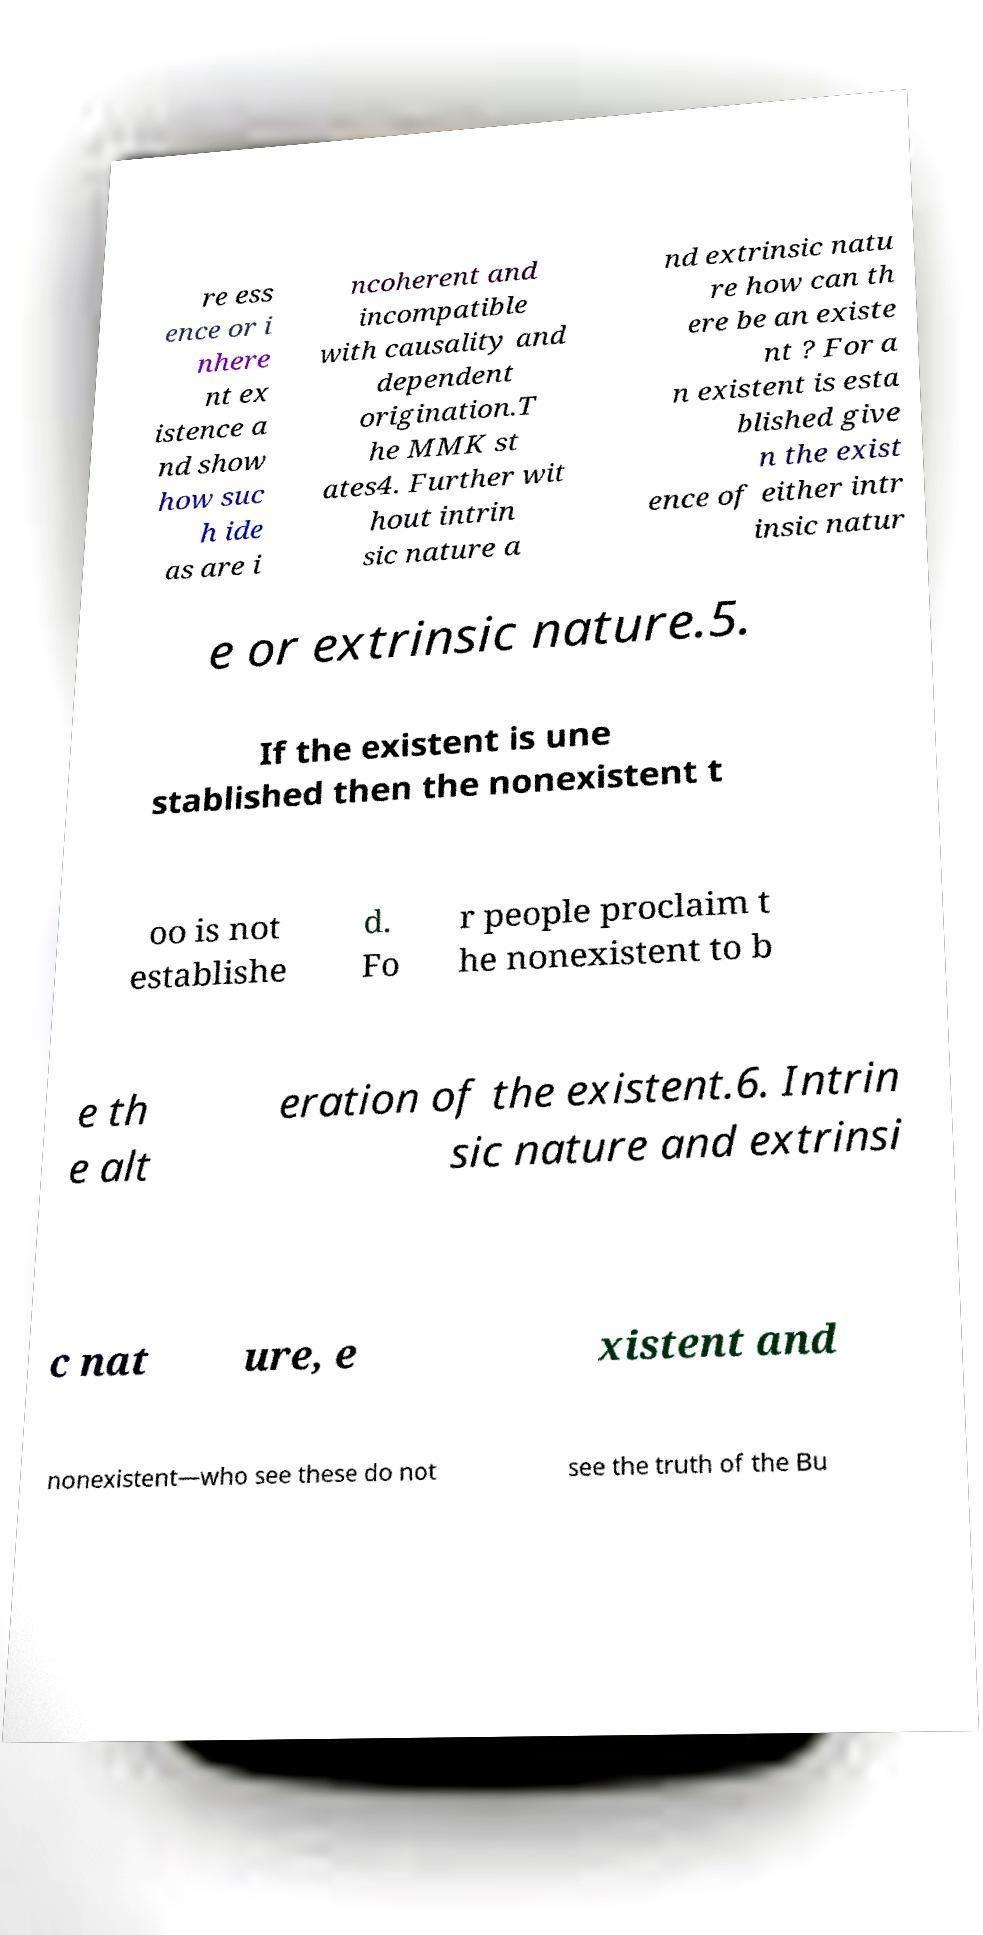Could you assist in decoding the text presented in this image and type it out clearly? re ess ence or i nhere nt ex istence a nd show how suc h ide as are i ncoherent and incompatible with causality and dependent origination.T he MMK st ates4. Further wit hout intrin sic nature a nd extrinsic natu re how can th ere be an existe nt ? For a n existent is esta blished give n the exist ence of either intr insic natur e or extrinsic nature.5. If the existent is une stablished then the nonexistent t oo is not establishe d. Fo r people proclaim t he nonexistent to b e th e alt eration of the existent.6. Intrin sic nature and extrinsi c nat ure, e xistent and nonexistent—who see these do not see the truth of the Bu 